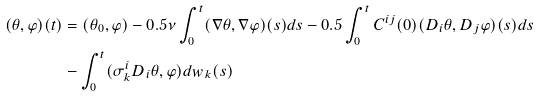<formula> <loc_0><loc_0><loc_500><loc_500>( \theta , \varphi ) ( t ) & = ( \theta _ { 0 } , \varphi ) - 0 . 5 \nu \int _ { 0 } ^ { t } ( \nabla \theta , \nabla \varphi ) ( s ) d s - 0 . 5 \int _ { 0 } ^ { t } C ^ { i j } ( 0 ) ( D _ { i } \theta , D _ { j } \varphi ) ( s ) d s \\ & - \int _ { 0 } ^ { t } ( \sigma ^ { i } _ { k } D _ { i } \theta , \varphi ) d w _ { k } ( s )</formula> 